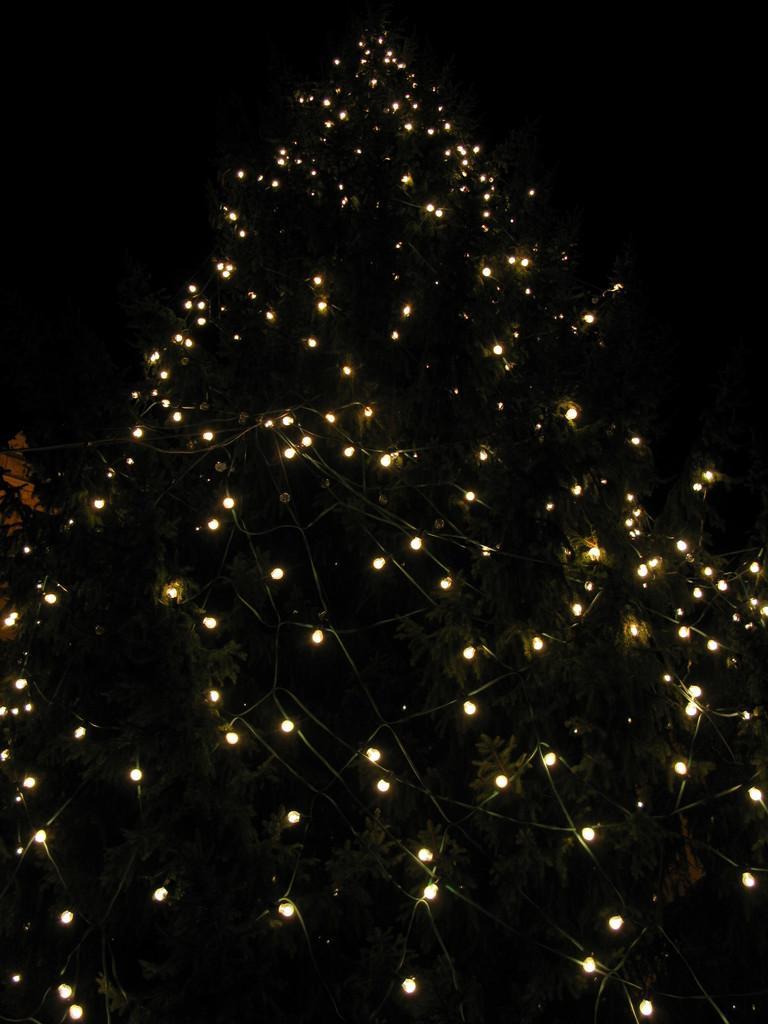In one or two sentences, can you explain what this image depicts? In this image there is a Christmas tree, there is a Christmas tree truncated towards the bottom of the image, there are lights on the Christmas tree, there is a building truncated towards the left of the image, the background of the image is dark. 